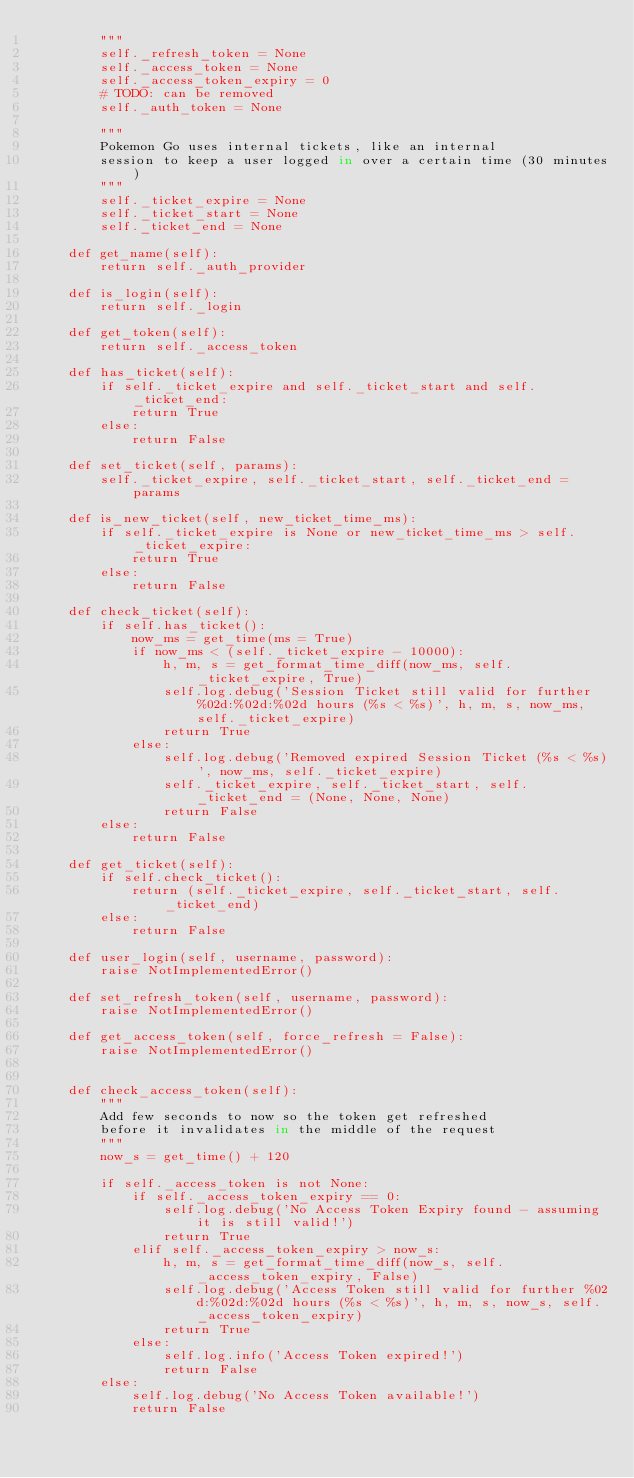<code> <loc_0><loc_0><loc_500><loc_500><_Python_>        """
        self._refresh_token = None
        self._access_token = None
        self._access_token_expiry = 0
        # TODO: can be removed
        self._auth_token = None

        """ 
        Pokemon Go uses internal tickets, like an internal 
        session to keep a user logged in over a certain time (30 minutes)
        """
        self._ticket_expire = None
        self._ticket_start = None
        self._ticket_end = None

    def get_name(self):
        return self._auth_provider

    def is_login(self):
        return self._login

    def get_token(self):
        return self._access_token

    def has_ticket(self):
        if self._ticket_expire and self._ticket_start and self._ticket_end:
            return True
        else:
            return False

    def set_ticket(self, params):
        self._ticket_expire, self._ticket_start, self._ticket_end = params

    def is_new_ticket(self, new_ticket_time_ms):
        if self._ticket_expire is None or new_ticket_time_ms > self._ticket_expire:
            return True
        else:
            return False

    def check_ticket(self):
        if self.has_ticket():
            now_ms = get_time(ms = True)
            if now_ms < (self._ticket_expire - 10000):
                h, m, s = get_format_time_diff(now_ms, self._ticket_expire, True)
                self.log.debug('Session Ticket still valid for further %02d:%02d:%02d hours (%s < %s)', h, m, s, now_ms, self._ticket_expire)
                return True
            else:
                self.log.debug('Removed expired Session Ticket (%s < %s)', now_ms, self._ticket_expire)
                self._ticket_expire, self._ticket_start, self._ticket_end = (None, None, None)
                return False
        else:
            return False

    def get_ticket(self):
        if self.check_ticket():
            return (self._ticket_expire, self._ticket_start, self._ticket_end)
        else:
            return False

    def user_login(self, username, password):
        raise NotImplementedError()

    def set_refresh_token(self, username, password):
        raise NotImplementedError()

    def get_access_token(self, force_refresh = False):
        raise NotImplementedError()


    def check_access_token(self):
        """
        Add few seconds to now so the token get refreshed 
        before it invalidates in the middle of the request
        """
        now_s = get_time() + 120

        if self._access_token is not None:
            if self._access_token_expiry == 0:
                self.log.debug('No Access Token Expiry found - assuming it is still valid!')
                return True
            elif self._access_token_expiry > now_s:
                h, m, s = get_format_time_diff(now_s, self._access_token_expiry, False)
                self.log.debug('Access Token still valid for further %02d:%02d:%02d hours (%s < %s)', h, m, s, now_s, self._access_token_expiry)
                return True
            else:
                self.log.info('Access Token expired!')
                return False
        else:
            self.log.debug('No Access Token available!')
            return False</code> 